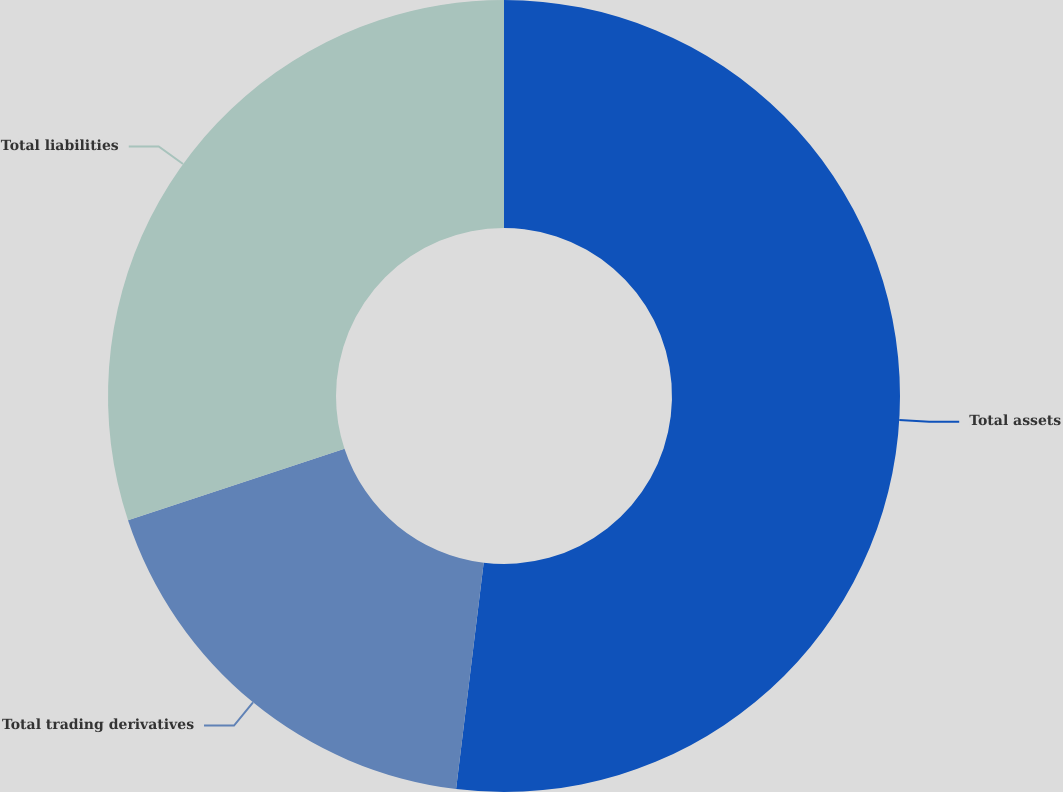Convert chart. <chart><loc_0><loc_0><loc_500><loc_500><pie_chart><fcel>Total assets<fcel>Total trading derivatives<fcel>Total liabilities<nl><fcel>51.93%<fcel>17.99%<fcel>30.08%<nl></chart> 